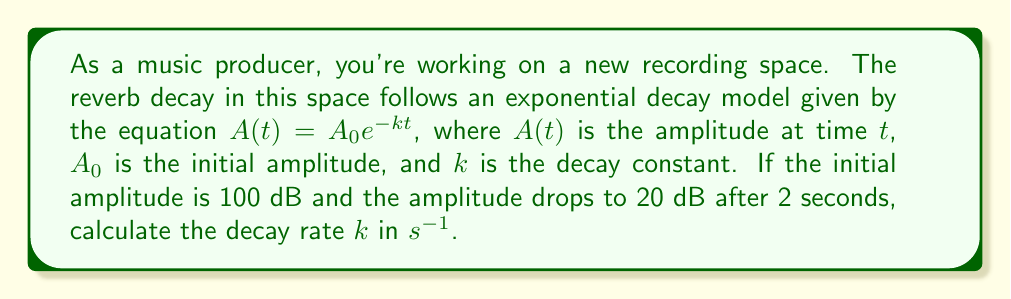Show me your answer to this math problem. To solve this problem, we'll follow these steps:

1) We're given the exponential decay model: $A(t) = A_0e^{-kt}$

2) We know:
   $A_0 = 100$ dB (initial amplitude)
   $A(2) = 20$ dB (amplitude after 2 seconds)
   $t = 2$ seconds

3) Let's plug these values into the equation:

   $20 = 100e^{-k(2)}$

4) Divide both sides by 100:

   $\frac{20}{100} = e^{-2k}$

5) Take the natural logarithm of both sides:

   $\ln(\frac{1}{5}) = -2k$

6) Simplify:

   $-\ln(5) = -2k$

7) Solve for $k$:

   $k = \frac{\ln(5)}{2}$

8) Calculate the value:

   $k \approx 0.8047$ $s^{-1}$

This $k$ value represents the decay rate of the reverb in the recording space.
Answer: $k = \frac{\ln(5)}{2} \approx 0.8047$ $s^{-1}$ 